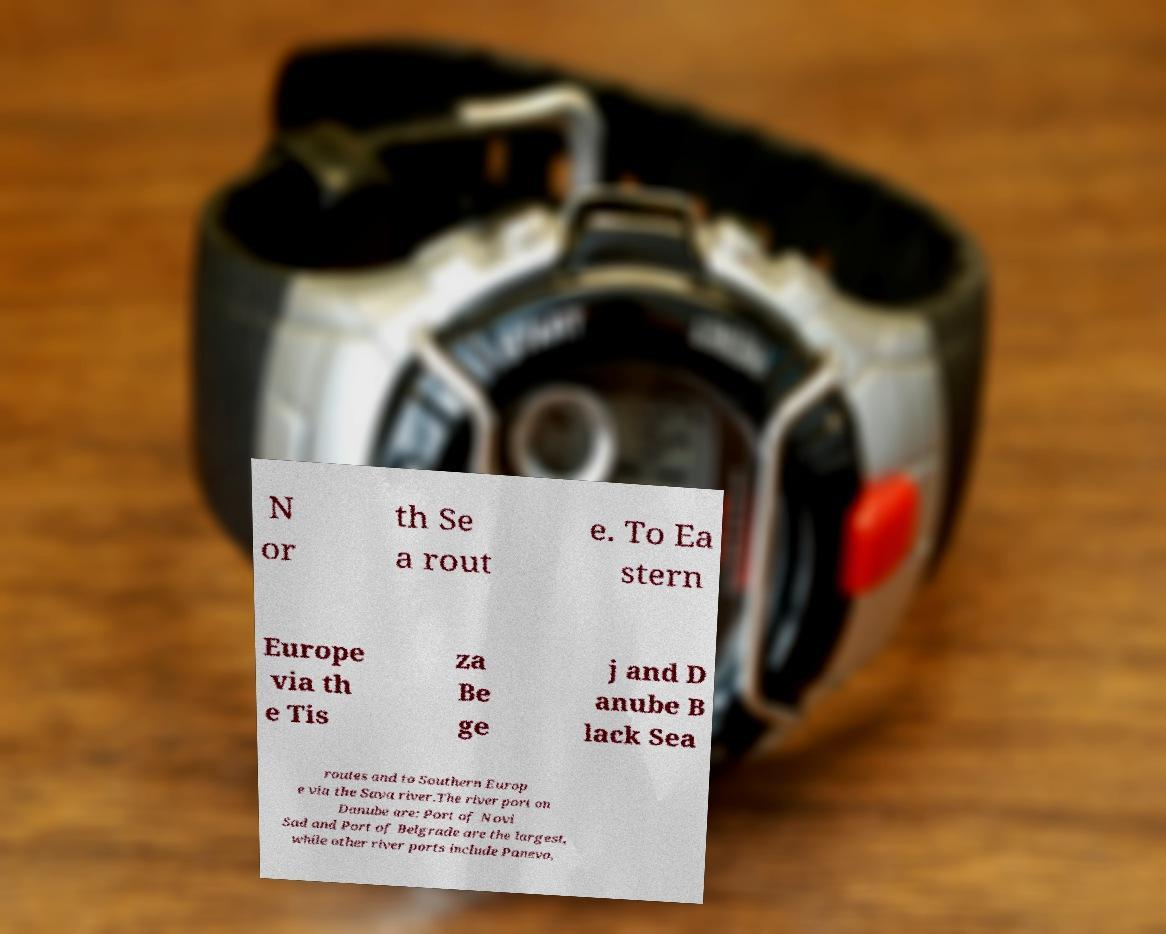Please identify and transcribe the text found in this image. N or th Se a rout e. To Ea stern Europe via th e Tis za Be ge j and D anube B lack Sea routes and to Southern Europ e via the Sava river.The river port on Danube are: Port of Novi Sad and Port of Belgrade are the largest, while other river ports include Panevo, 